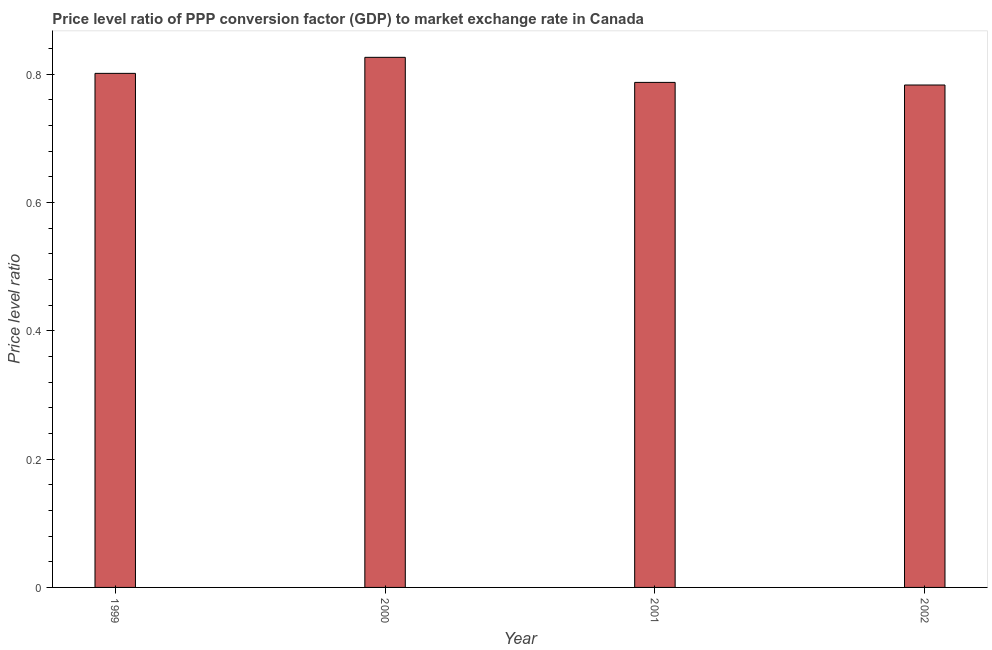Does the graph contain any zero values?
Offer a terse response. No. Does the graph contain grids?
Provide a succinct answer. No. What is the title of the graph?
Your response must be concise. Price level ratio of PPP conversion factor (GDP) to market exchange rate in Canada. What is the label or title of the Y-axis?
Keep it short and to the point. Price level ratio. What is the price level ratio in 2000?
Your response must be concise. 0.83. Across all years, what is the maximum price level ratio?
Ensure brevity in your answer.  0.83. Across all years, what is the minimum price level ratio?
Offer a very short reply. 0.78. In which year was the price level ratio maximum?
Your answer should be compact. 2000. What is the sum of the price level ratio?
Offer a terse response. 3.2. What is the difference between the price level ratio in 1999 and 2000?
Make the answer very short. -0.03. What is the median price level ratio?
Give a very brief answer. 0.79. Do a majority of the years between 1999 and 2002 (inclusive) have price level ratio greater than 0.32 ?
Offer a very short reply. Yes. Is the price level ratio in 2000 less than that in 2002?
Offer a very short reply. No. What is the difference between the highest and the second highest price level ratio?
Provide a short and direct response. 0.03. How many years are there in the graph?
Make the answer very short. 4. What is the difference between two consecutive major ticks on the Y-axis?
Give a very brief answer. 0.2. What is the Price level ratio in 1999?
Offer a terse response. 0.8. What is the Price level ratio in 2000?
Keep it short and to the point. 0.83. What is the Price level ratio of 2001?
Your response must be concise. 0.79. What is the Price level ratio in 2002?
Provide a short and direct response. 0.78. What is the difference between the Price level ratio in 1999 and 2000?
Provide a short and direct response. -0.03. What is the difference between the Price level ratio in 1999 and 2001?
Your response must be concise. 0.01. What is the difference between the Price level ratio in 1999 and 2002?
Keep it short and to the point. 0.02. What is the difference between the Price level ratio in 2000 and 2001?
Provide a succinct answer. 0.04. What is the difference between the Price level ratio in 2000 and 2002?
Offer a terse response. 0.04. What is the difference between the Price level ratio in 2001 and 2002?
Give a very brief answer. 0. What is the ratio of the Price level ratio in 1999 to that in 2001?
Keep it short and to the point. 1.02. What is the ratio of the Price level ratio in 1999 to that in 2002?
Your response must be concise. 1.02. What is the ratio of the Price level ratio in 2000 to that in 2001?
Offer a terse response. 1.05. What is the ratio of the Price level ratio in 2000 to that in 2002?
Offer a very short reply. 1.05. What is the ratio of the Price level ratio in 2001 to that in 2002?
Ensure brevity in your answer.  1. 